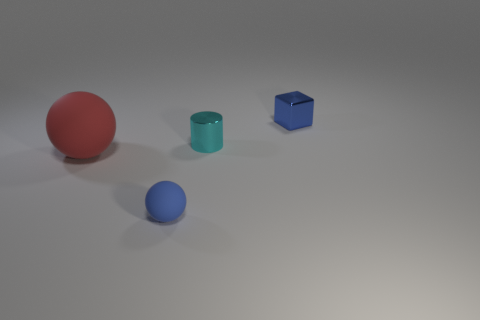Are there any other things that have the same material as the big ball?
Give a very brief answer. Yes. Are there an equal number of small blue objects that are behind the red thing and cyan cylinders?
Ensure brevity in your answer.  Yes. How many small blue objects have the same shape as the big red object?
Keep it short and to the point. 1. How big is the sphere left of the object that is in front of the red matte thing that is in front of the small cyan thing?
Make the answer very short. Large. Is the small blue thing that is right of the small blue rubber sphere made of the same material as the tiny cylinder?
Your response must be concise. Yes. Is the number of things that are in front of the large red matte ball the same as the number of blue cubes that are to the right of the cyan cylinder?
Ensure brevity in your answer.  Yes. Is there any other thing that has the same size as the blue ball?
Give a very brief answer. Yes. There is a large red object that is the same shape as the blue rubber object; what is it made of?
Provide a succinct answer. Rubber. Is there a tiny blue rubber thing in front of the blue thing on the right side of the tiny thing that is in front of the large matte sphere?
Keep it short and to the point. Yes. There is a tiny blue object to the right of the cyan shiny thing; does it have the same shape as the blue object in front of the tiny cyan object?
Your answer should be compact. No. 